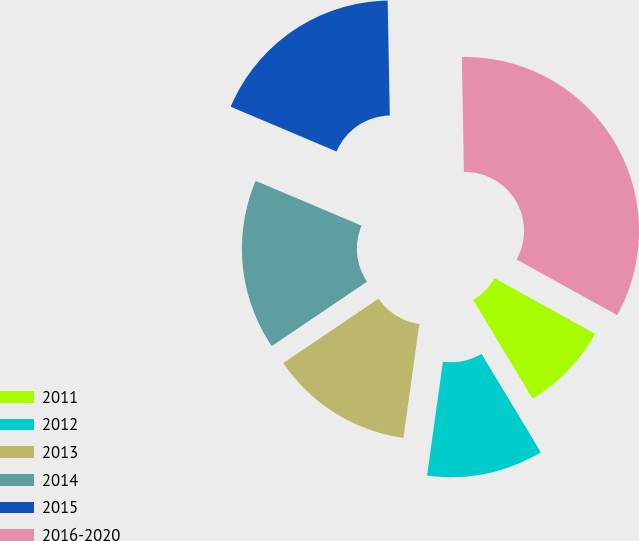Convert chart. <chart><loc_0><loc_0><loc_500><loc_500><pie_chart><fcel>2011<fcel>2012<fcel>2013<fcel>2014<fcel>2015<fcel>2016-2020<nl><fcel>8.33%<fcel>10.83%<fcel>13.33%<fcel>15.83%<fcel>18.33%<fcel>33.33%<nl></chart> 